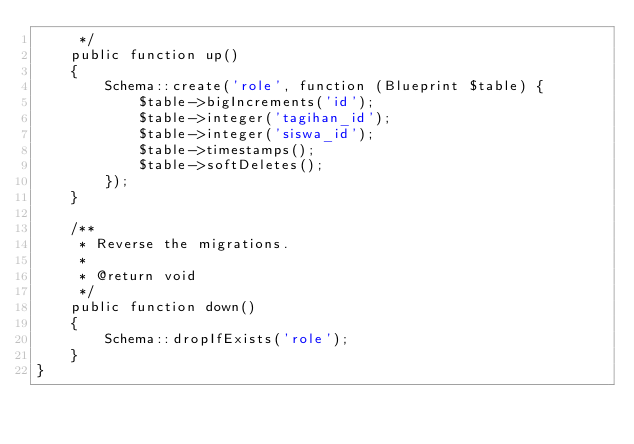<code> <loc_0><loc_0><loc_500><loc_500><_PHP_>     */
    public function up()
    {
        Schema::create('role', function (Blueprint $table) {
            $table->bigIncrements('id');
            $table->integer('tagihan_id');
            $table->integer('siswa_id');
            $table->timestamps();
            $table->softDeletes();
        });
    }

    /**
     * Reverse the migrations.
     *
     * @return void
     */
    public function down()
    {
        Schema::dropIfExists('role');
    }
}
</code> 